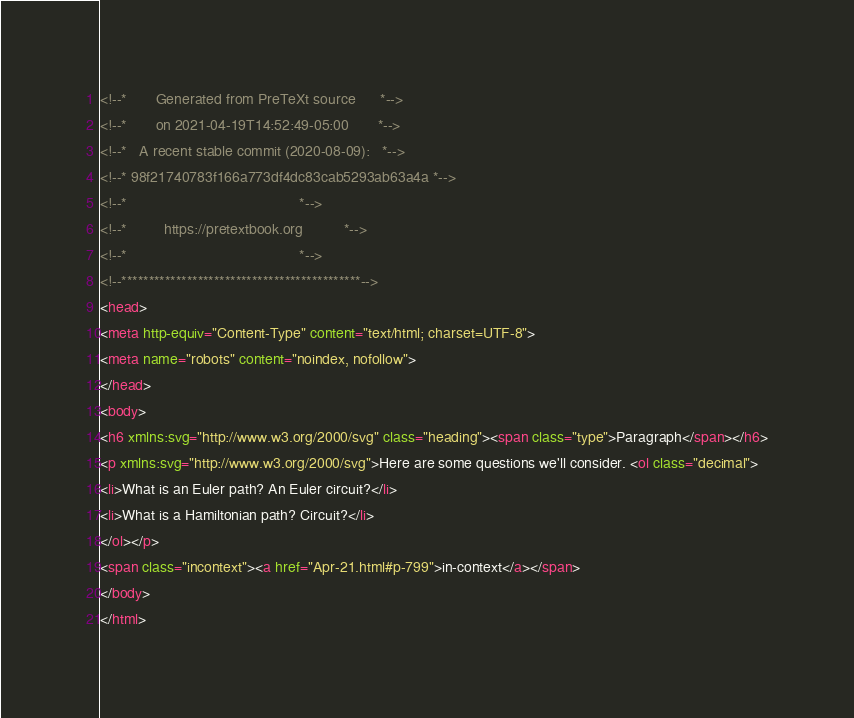<code> <loc_0><loc_0><loc_500><loc_500><_HTML_><!--*       Generated from PreTeXt source      *-->
<!--*       on 2021-04-19T14:52:49-05:00       *-->
<!--*   A recent stable commit (2020-08-09):   *-->
<!--* 98f21740783f166a773df4dc83cab5293ab63a4a *-->
<!--*                                          *-->
<!--*         https://pretextbook.org          *-->
<!--*                                          *-->
<!--********************************************-->
<head>
<meta http-equiv="Content-Type" content="text/html; charset=UTF-8">
<meta name="robots" content="noindex, nofollow">
</head>
<body>
<h6 xmlns:svg="http://www.w3.org/2000/svg" class="heading"><span class="type">Paragraph</span></h6>
<p xmlns:svg="http://www.w3.org/2000/svg">Here are some questions we'll consider. <ol class="decimal">
<li>What is an Euler path? An Euler circuit?</li>
<li>What is a Hamiltonian path? Circuit?</li>
</ol></p>
<span class="incontext"><a href="Apr-21.html#p-799">in-context</a></span>
</body>
</html>
</code> 